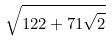<formula> <loc_0><loc_0><loc_500><loc_500>\sqrt { 1 2 2 + 7 1 \sqrt { 2 } }</formula> 